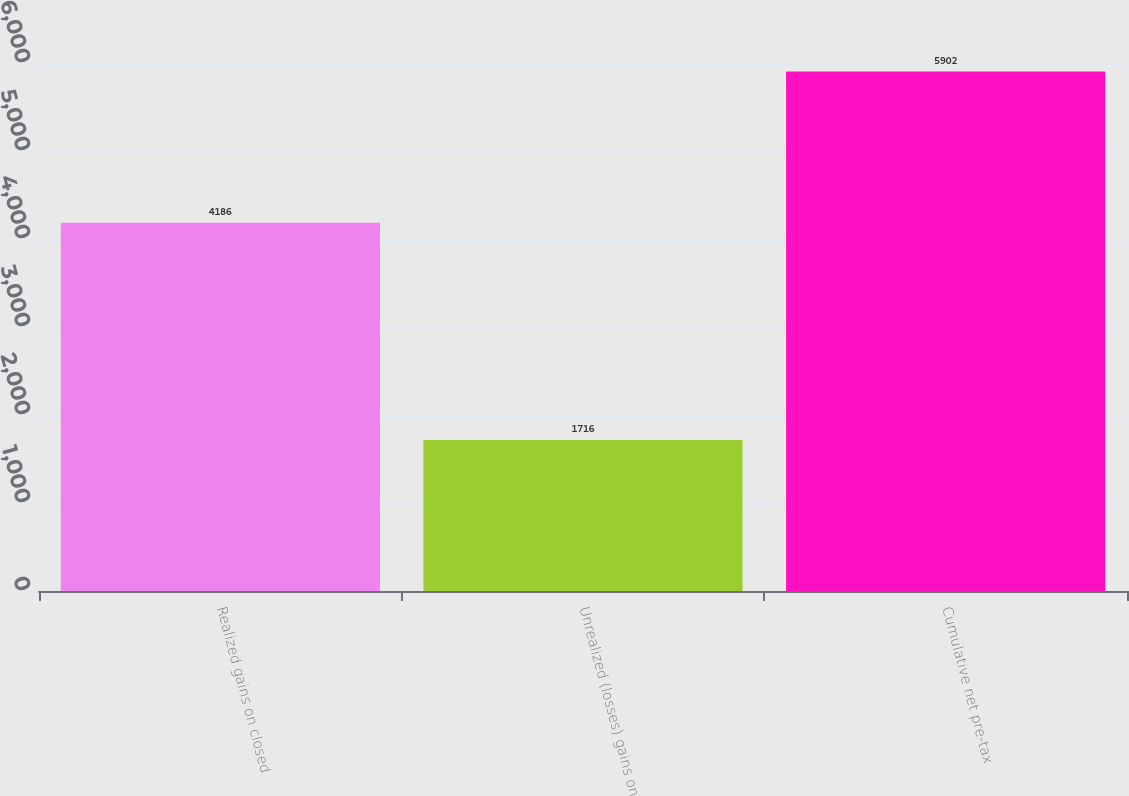Convert chart. <chart><loc_0><loc_0><loc_500><loc_500><bar_chart><fcel>Realized gains on closed<fcel>Unrealized (losses) gains on<fcel>Cumulative net pre-tax<nl><fcel>4186<fcel>1716<fcel>5902<nl></chart> 